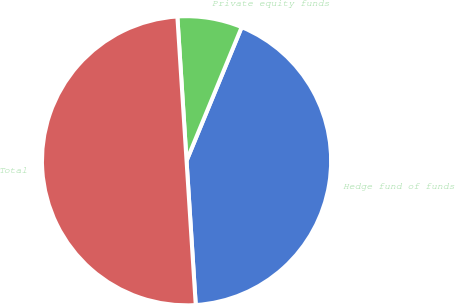Convert chart to OTSL. <chart><loc_0><loc_0><loc_500><loc_500><pie_chart><fcel>Hedge fund of funds<fcel>Private equity funds<fcel>Total<nl><fcel>42.76%<fcel>7.24%<fcel>50.0%<nl></chart> 